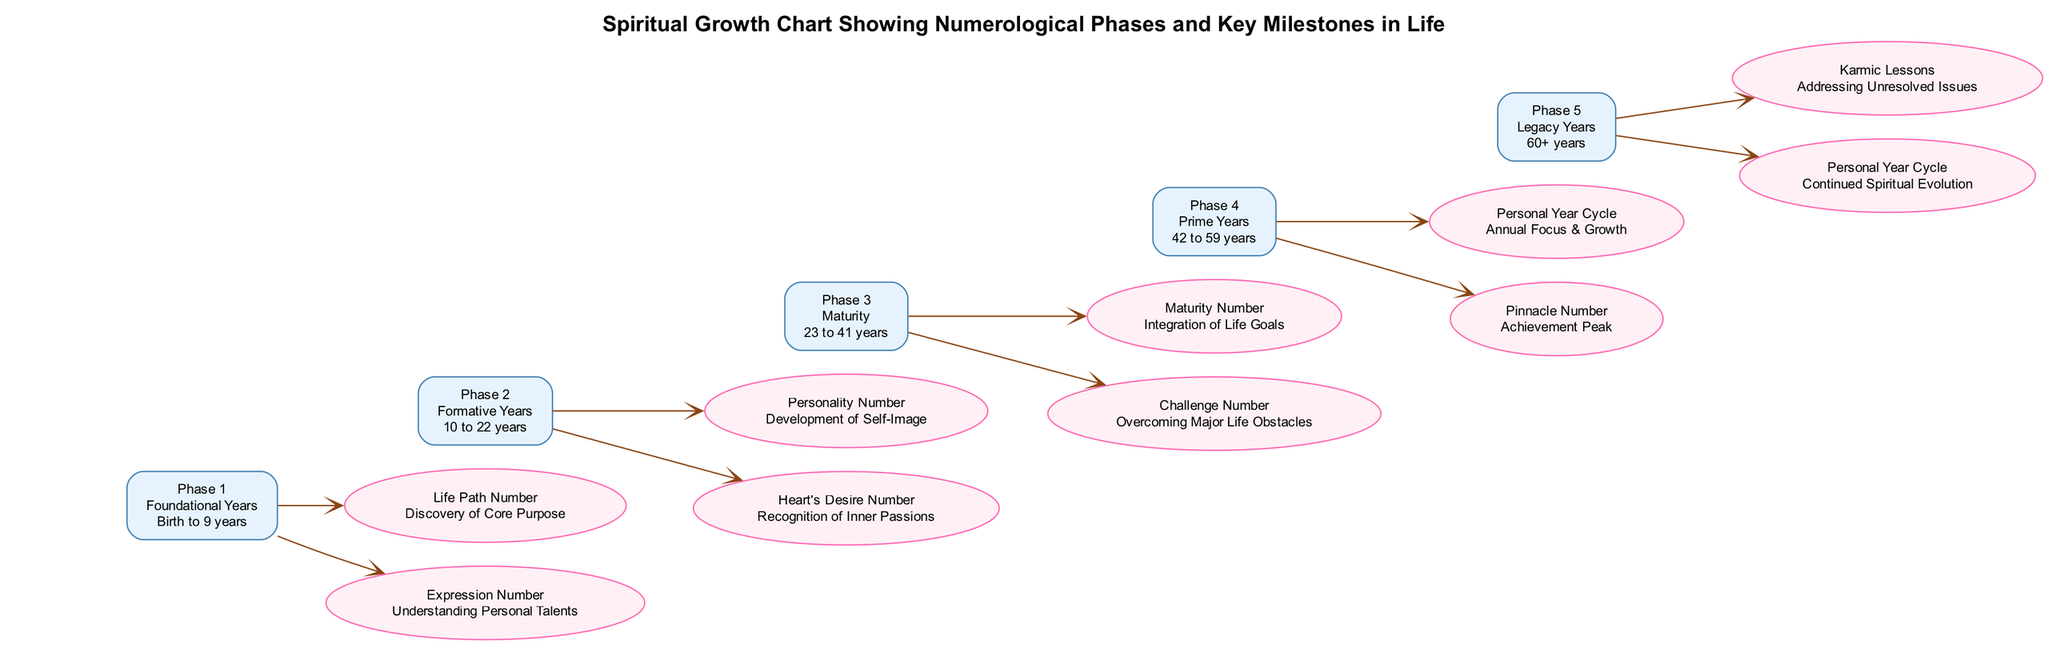What is the age range for Phase 3? The description of Phase 3, titled "Maturity," indicates the age range is from 23 to 41 years. This is stated directly in the diagram.
Answer: 23 to 41 years How many milestones are listed under Phase 4? Phase 4, labeled "Prime Years," includes two milestones: "Personal Year Cycle" and "Pinnacle Number." By counting the milestones listed under this phase, we can confirm there are two.
Answer: 2 Which number corresponds to the milestone "Life Path Number"? The milestone "Life Path Number" appears under Phase 1, which is the first phase. The numbering corresponds to the order of phases, thus "Life Path Number" is associated with the number one.
Answer: 1 What does the "Challenge Number" milestone signify? The description of the "Challenge Number" milestone states it relates to "Overcoming Major Life Obstacles." This explanation directly follows from the milestone's description listed under Phase 3 in the diagram.
Answer: Overcoming Major Life Obstacles In which phase is the "Heart's Desire Number" found? The "Heart's Desire Number" is identified as a milestone in Phase 2, titled "Formative Years." By reviewing the milestones for each phase, we see this milestone falls under the second phase.
Answer: Phase 2 What is the title of Phase 5? According to the diagram data, Phase 5 is titled "Legacy Years." This is explicitly stated in the phase details, making it straightforward to answer.
Answer: Legacy Years How many phases are depicted in the diagram? The diagram contains a total of five phases: Phase 1 through Phase 5. By summarizing the elements in the diagram, we confirm there are five distinct phases.
Answer: 5 What milestone in Phase 1 relates to personal talents? The milestone in Phase 1 associated with personal talents is the "Expression Number," which is explicitly listed with its description.
Answer: Expression Number 